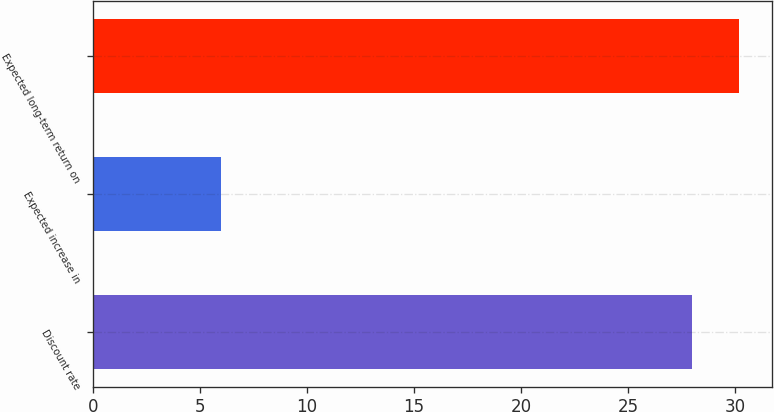<chart> <loc_0><loc_0><loc_500><loc_500><bar_chart><fcel>Discount rate<fcel>Expected increase in<fcel>Expected long-term return on<nl><fcel>28<fcel>6<fcel>30.2<nl></chart> 